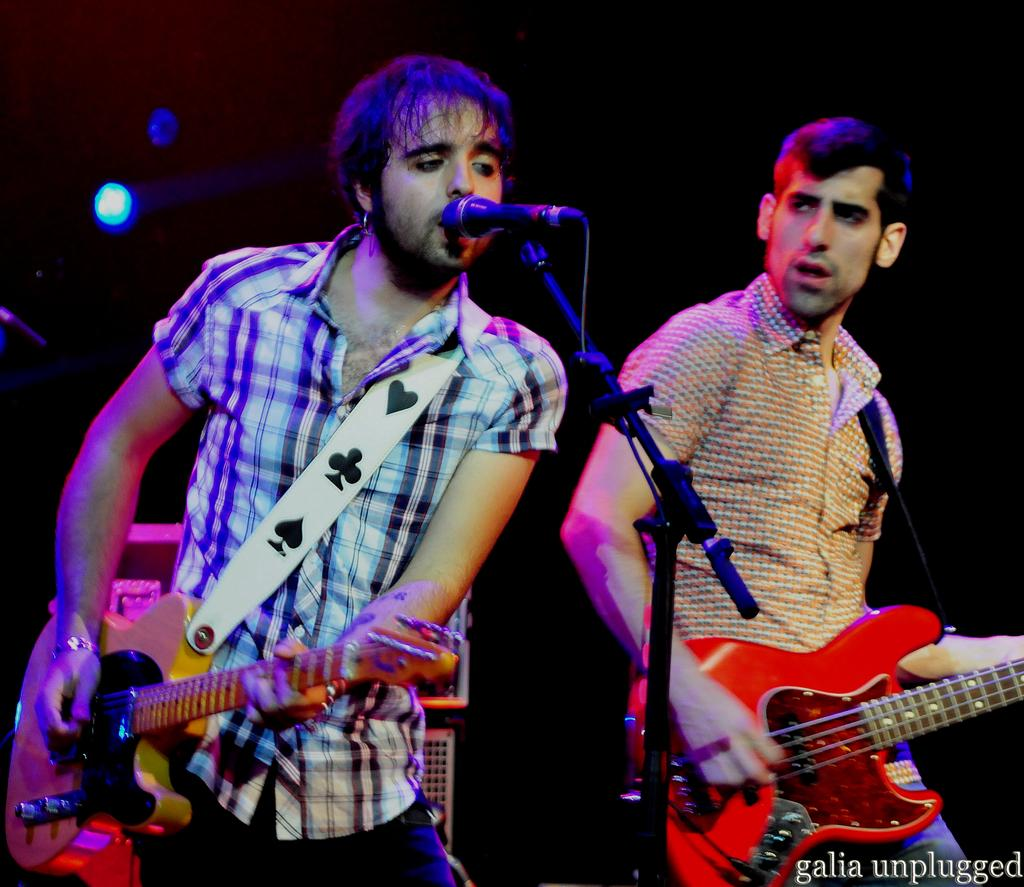How many people are in the image? There are two men in the image. What are the men doing in the image? The men are standing and playing guitars. How are the guitars being held by the men? The guitars are in their hands. What other object can be seen in the image related to music? There is a microphone in the image. What is the purpose of the stand in the image? The stand is likely used to hold the microphone. What can be observed about the lighting in the image? The background of the image is dark. What type of soda is being poured into the guitar in the image? There is no soda present in the image, and no pouring of any liquid is depicted. 